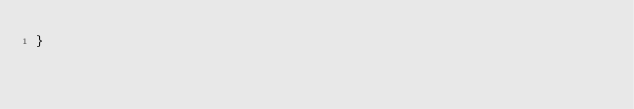Convert code to text. <code><loc_0><loc_0><loc_500><loc_500><_Scala_>}
</code> 